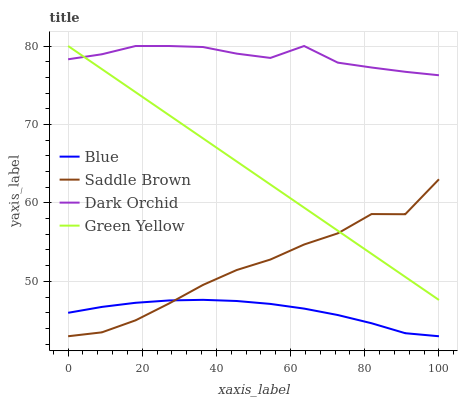Does Blue have the minimum area under the curve?
Answer yes or no. Yes. Does Dark Orchid have the maximum area under the curve?
Answer yes or no. Yes. Does Green Yellow have the minimum area under the curve?
Answer yes or no. No. Does Green Yellow have the maximum area under the curve?
Answer yes or no. No. Is Green Yellow the smoothest?
Answer yes or no. Yes. Is Saddle Brown the roughest?
Answer yes or no. Yes. Is Saddle Brown the smoothest?
Answer yes or no. No. Is Green Yellow the roughest?
Answer yes or no. No. Does Blue have the lowest value?
Answer yes or no. Yes. Does Green Yellow have the lowest value?
Answer yes or no. No. Does Dark Orchid have the highest value?
Answer yes or no. Yes. Does Saddle Brown have the highest value?
Answer yes or no. No. Is Blue less than Dark Orchid?
Answer yes or no. Yes. Is Green Yellow greater than Blue?
Answer yes or no. Yes. Does Blue intersect Saddle Brown?
Answer yes or no. Yes. Is Blue less than Saddle Brown?
Answer yes or no. No. Is Blue greater than Saddle Brown?
Answer yes or no. No. Does Blue intersect Dark Orchid?
Answer yes or no. No. 